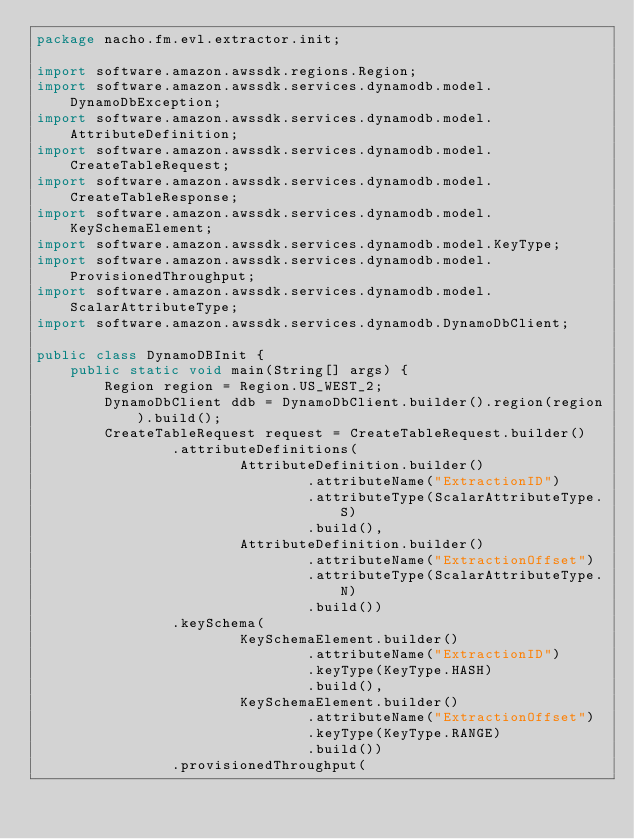<code> <loc_0><loc_0><loc_500><loc_500><_Java_>package nacho.fm.evl.extractor.init;

import software.amazon.awssdk.regions.Region;
import software.amazon.awssdk.services.dynamodb.model.DynamoDbException;
import software.amazon.awssdk.services.dynamodb.model.AttributeDefinition;
import software.amazon.awssdk.services.dynamodb.model.CreateTableRequest;
import software.amazon.awssdk.services.dynamodb.model.CreateTableResponse;
import software.amazon.awssdk.services.dynamodb.model.KeySchemaElement;
import software.amazon.awssdk.services.dynamodb.model.KeyType;
import software.amazon.awssdk.services.dynamodb.model.ProvisionedThroughput;
import software.amazon.awssdk.services.dynamodb.model.ScalarAttributeType;
import software.amazon.awssdk.services.dynamodb.DynamoDbClient;

public class DynamoDBInit {
    public static void main(String[] args) {
        Region region = Region.US_WEST_2;
        DynamoDbClient ddb = DynamoDbClient.builder().region(region).build();
        CreateTableRequest request = CreateTableRequest.builder()
                .attributeDefinitions(
                        AttributeDefinition.builder()
                                .attributeName("ExtractionID")
                                .attributeType(ScalarAttributeType.S)
                                .build(),
                        AttributeDefinition.builder()
                                .attributeName("ExtractionOffset")
                                .attributeType(ScalarAttributeType.N)
                                .build())
                .keySchema(
                        KeySchemaElement.builder()
                                .attributeName("ExtractionID")
                                .keyType(KeyType.HASH)
                                .build(),
                        KeySchemaElement.builder()
                                .attributeName("ExtractionOffset")
                                .keyType(KeyType.RANGE)
                                .build())
                .provisionedThroughput(</code> 